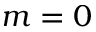<formula> <loc_0><loc_0><loc_500><loc_500>m = 0</formula> 